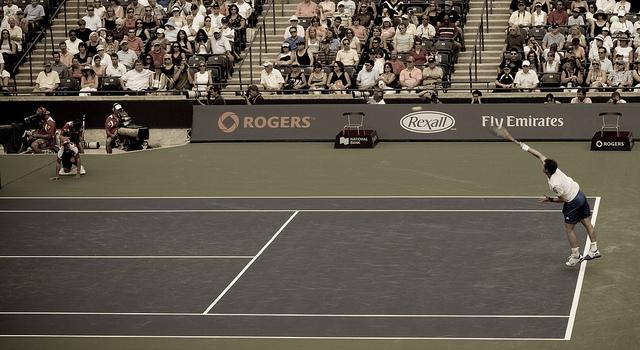What does Fly Emirates provide to the game? Please explain your reasoning. sponsor. Sponsors are generally displayed on the boards of tennis games. 